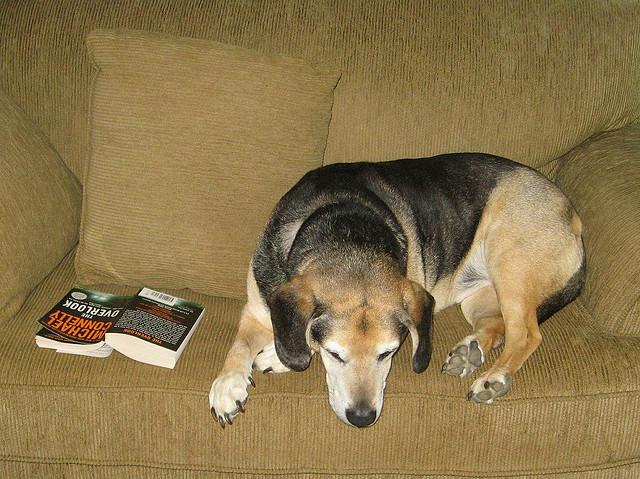Is the book open?
Keep it brief. Yes. Is the dog sleeping or playing?
Be succinct. Sleeping. Is this a couch?
Give a very brief answer. Yes. 